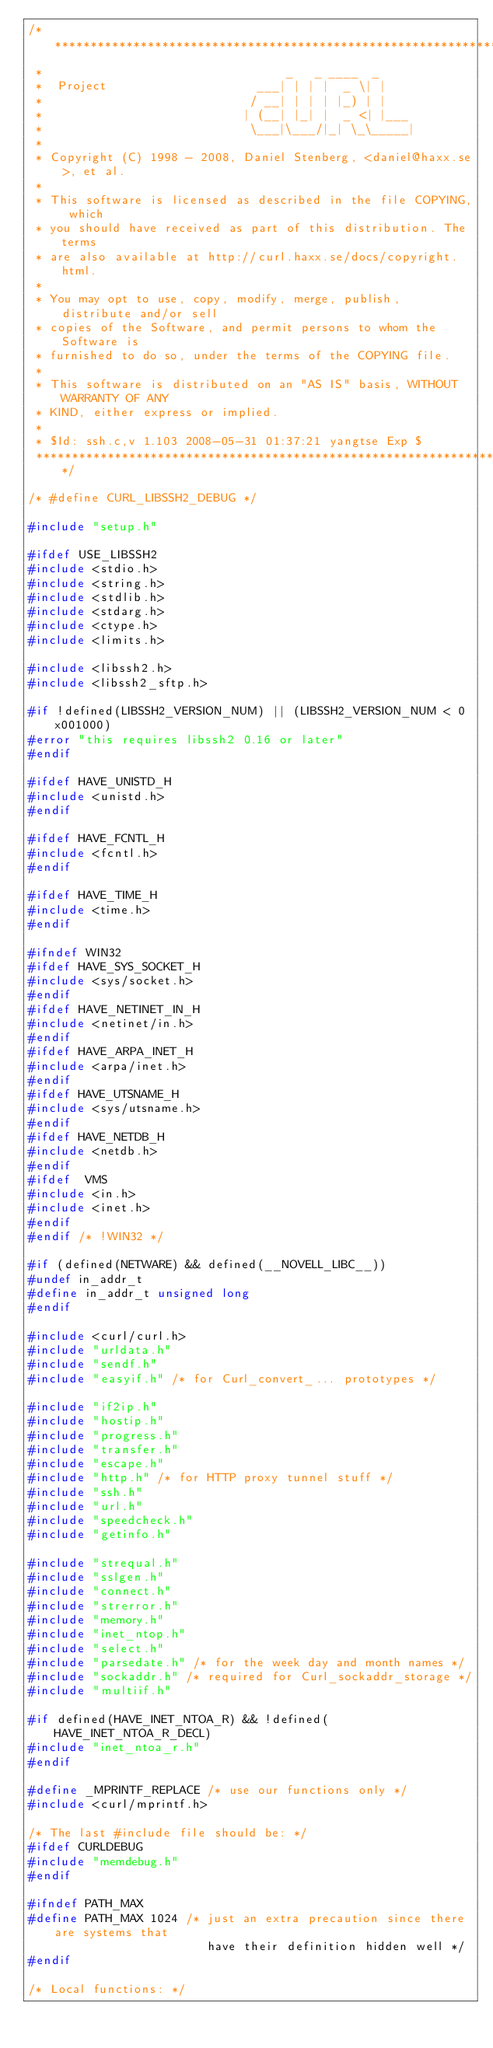Convert code to text. <code><loc_0><loc_0><loc_500><loc_500><_C_>/***************************************************************************
 *                                  _   _ ____  _
 *  Project                     ___| | | |  _ \| |
 *                             / __| | | | |_) | |
 *                            | (__| |_| |  _ <| |___
 *                             \___|\___/|_| \_\_____|
 *
 * Copyright (C) 1998 - 2008, Daniel Stenberg, <daniel@haxx.se>, et al.
 *
 * This software is licensed as described in the file COPYING, which
 * you should have received as part of this distribution. The terms
 * are also available at http://curl.haxx.se/docs/copyright.html.
 *
 * You may opt to use, copy, modify, merge, publish, distribute and/or sell
 * copies of the Software, and permit persons to whom the Software is
 * furnished to do so, under the terms of the COPYING file.
 *
 * This software is distributed on an "AS IS" basis, WITHOUT WARRANTY OF ANY
 * KIND, either express or implied.
 *
 * $Id: ssh.c,v 1.103 2008-05-31 01:37:21 yangtse Exp $
 ***************************************************************************/

/* #define CURL_LIBSSH2_DEBUG */

#include "setup.h"

#ifdef USE_LIBSSH2
#include <stdio.h>
#include <string.h>
#include <stdlib.h>
#include <stdarg.h>
#include <ctype.h>
#include <limits.h>

#include <libssh2.h>
#include <libssh2_sftp.h>

#if !defined(LIBSSH2_VERSION_NUM) || (LIBSSH2_VERSION_NUM < 0x001000)
#error "this requires libssh2 0.16 or later"
#endif

#ifdef HAVE_UNISTD_H
#include <unistd.h>
#endif

#ifdef HAVE_FCNTL_H
#include <fcntl.h>
#endif

#ifdef HAVE_TIME_H
#include <time.h>
#endif

#ifndef WIN32
#ifdef HAVE_SYS_SOCKET_H
#include <sys/socket.h>
#endif
#ifdef HAVE_NETINET_IN_H
#include <netinet/in.h>
#endif
#ifdef HAVE_ARPA_INET_H
#include <arpa/inet.h>
#endif
#ifdef HAVE_UTSNAME_H
#include <sys/utsname.h>
#endif
#ifdef HAVE_NETDB_H
#include <netdb.h>
#endif
#ifdef  VMS
#include <in.h>
#include <inet.h>
#endif
#endif /* !WIN32 */

#if (defined(NETWARE) && defined(__NOVELL_LIBC__))
#undef in_addr_t
#define in_addr_t unsigned long
#endif

#include <curl/curl.h>
#include "urldata.h"
#include "sendf.h"
#include "easyif.h" /* for Curl_convert_... prototypes */

#include "if2ip.h"
#include "hostip.h"
#include "progress.h"
#include "transfer.h"
#include "escape.h"
#include "http.h" /* for HTTP proxy tunnel stuff */
#include "ssh.h"
#include "url.h"
#include "speedcheck.h"
#include "getinfo.h"

#include "strequal.h"
#include "sslgen.h"
#include "connect.h"
#include "strerror.h"
#include "memory.h"
#include "inet_ntop.h"
#include "select.h"
#include "parsedate.h" /* for the week day and month names */
#include "sockaddr.h" /* required for Curl_sockaddr_storage */
#include "multiif.h"

#if defined(HAVE_INET_NTOA_R) && !defined(HAVE_INET_NTOA_R_DECL)
#include "inet_ntoa_r.h"
#endif

#define _MPRINTF_REPLACE /* use our functions only */
#include <curl/mprintf.h>

/* The last #include file should be: */
#ifdef CURLDEBUG
#include "memdebug.h"
#endif

#ifndef PATH_MAX
#define PATH_MAX 1024 /* just an extra precaution since there are systems that
                         have their definition hidden well */
#endif

/* Local functions: */</code> 